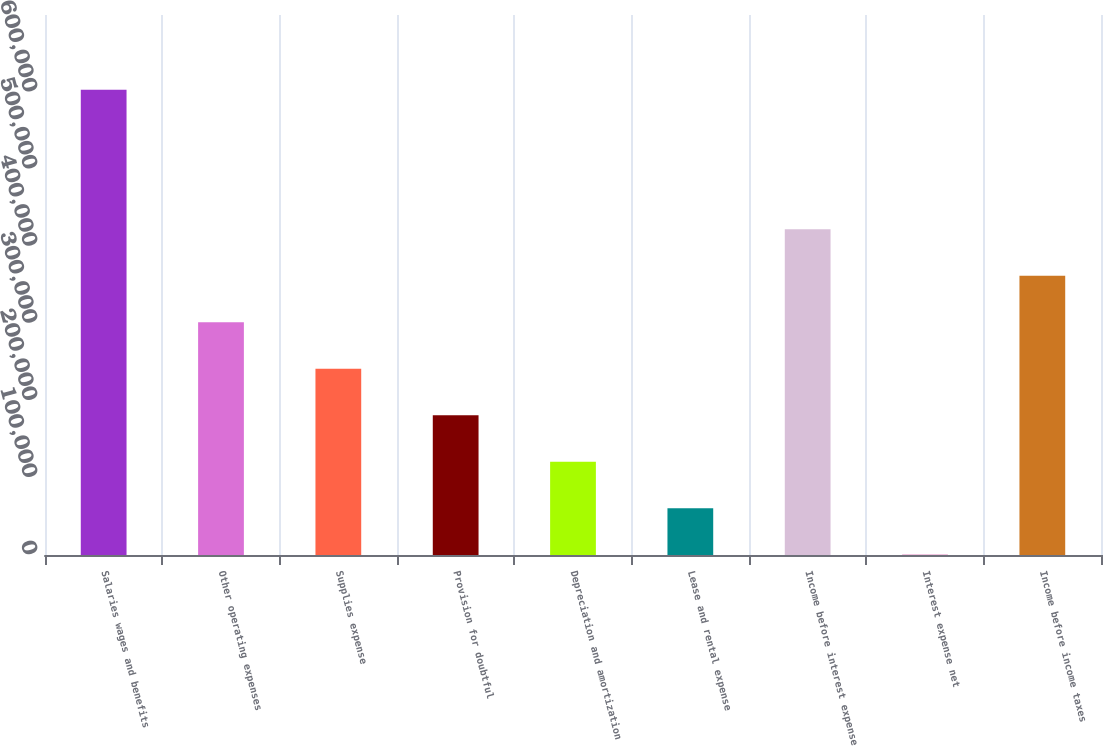Convert chart. <chart><loc_0><loc_0><loc_500><loc_500><bar_chart><fcel>Salaries wages and benefits<fcel>Other operating expenses<fcel>Supplies expense<fcel>Provision for doubtful<fcel>Depreciation and amortization<fcel>Lease and rental expense<fcel>Income before interest expense<fcel>Interest expense net<fcel>Income before income taxes<nl><fcel>603227<fcel>301752<fcel>241457<fcel>181162<fcel>120867<fcel>60572<fcel>422342<fcel>277<fcel>362047<nl></chart> 